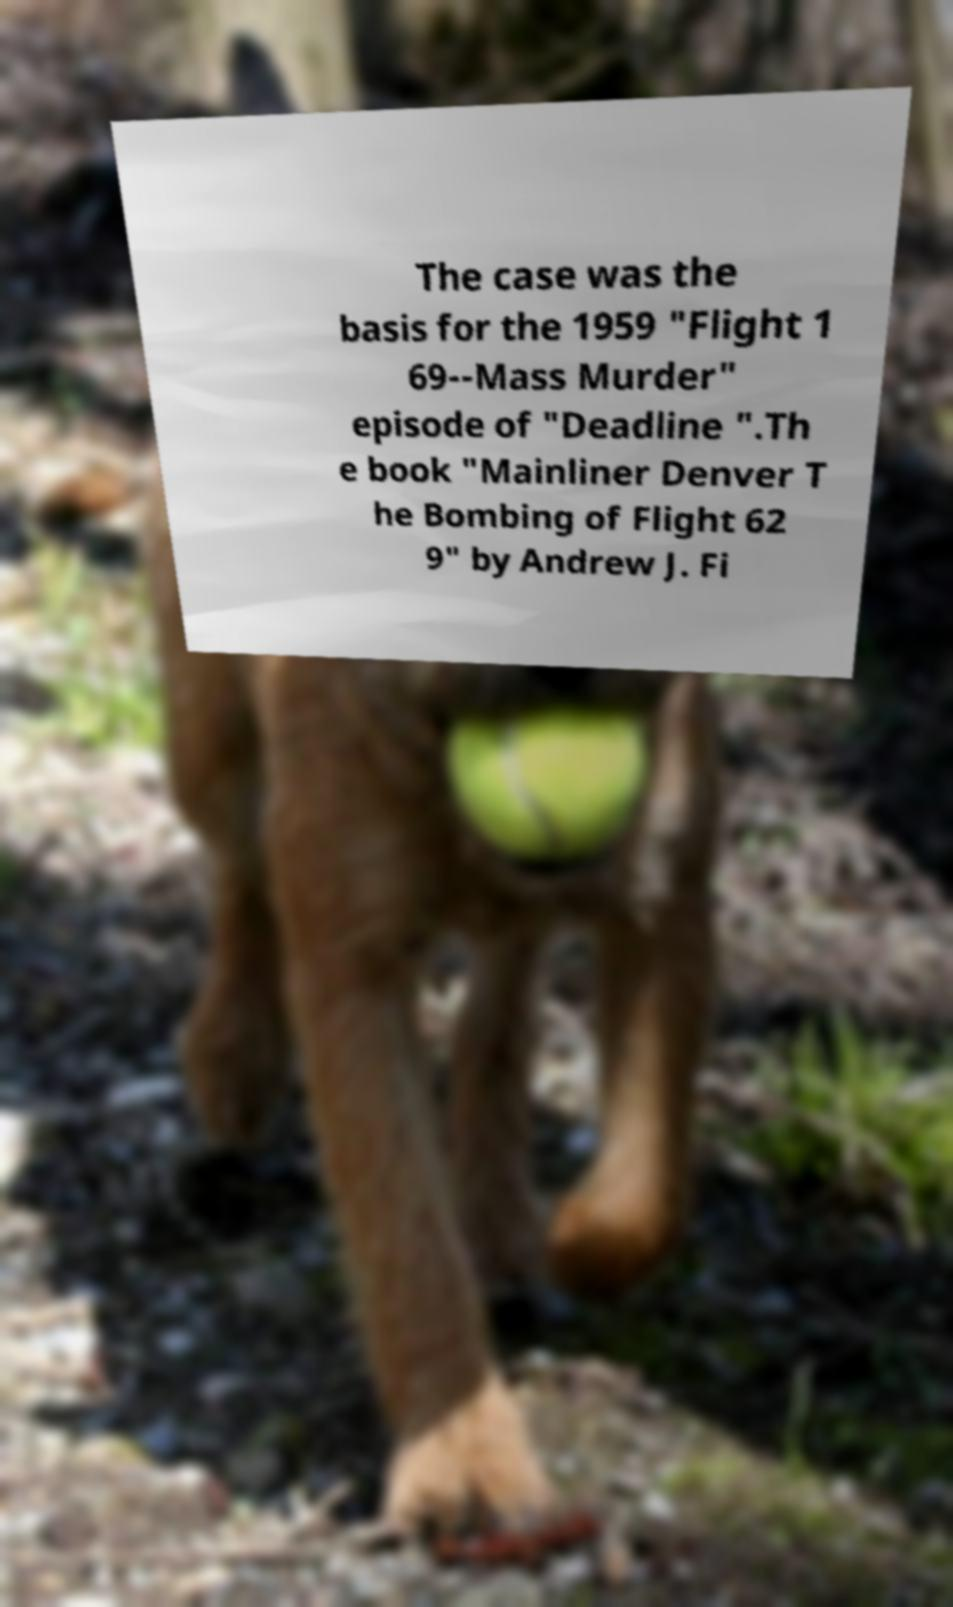Please read and relay the text visible in this image. What does it say? The case was the basis for the 1959 "Flight 1 69--Mass Murder" episode of "Deadline ".Th e book "Mainliner Denver T he Bombing of Flight 62 9" by Andrew J. Fi 